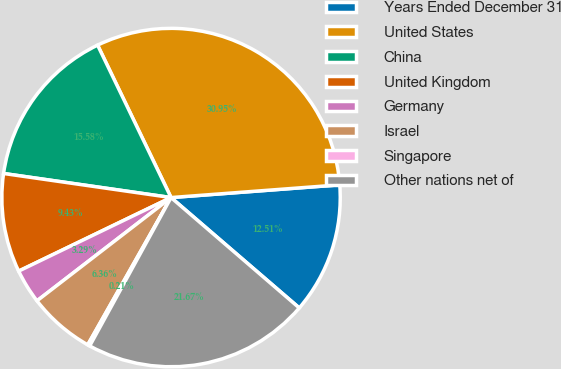Convert chart. <chart><loc_0><loc_0><loc_500><loc_500><pie_chart><fcel>Years Ended December 31<fcel>United States<fcel>China<fcel>United Kingdom<fcel>Germany<fcel>Israel<fcel>Singapore<fcel>Other nations net of<nl><fcel>12.51%<fcel>30.95%<fcel>15.58%<fcel>9.43%<fcel>3.29%<fcel>6.36%<fcel>0.21%<fcel>21.67%<nl></chart> 